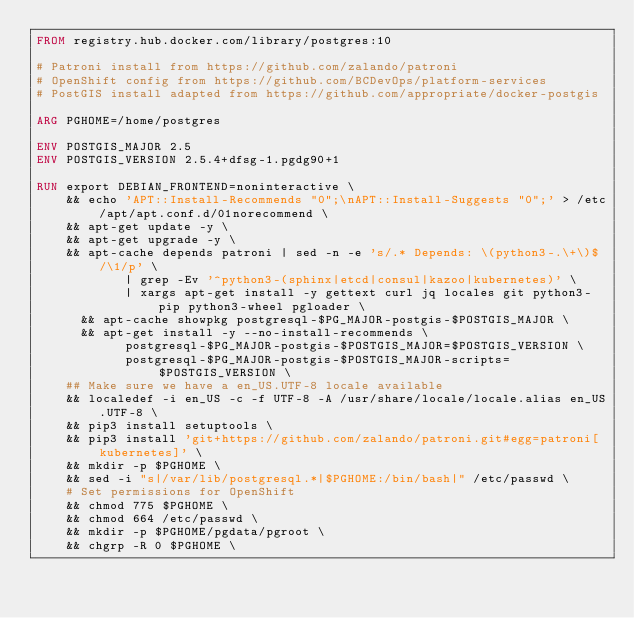Convert code to text. <code><loc_0><loc_0><loc_500><loc_500><_Dockerfile_>FROM registry.hub.docker.com/library/postgres:10

# Patroni install from https://github.com/zalando/patroni
# OpenShift config from https://github.com/BCDevOps/platform-services
# PostGIS install adapted from https://github.com/appropriate/docker-postgis

ARG PGHOME=/home/postgres

ENV POSTGIS_MAJOR 2.5
ENV POSTGIS_VERSION 2.5.4+dfsg-1.pgdg90+1

RUN export DEBIAN_FRONTEND=noninteractive \
    && echo 'APT::Install-Recommends "0";\nAPT::Install-Suggests "0";' > /etc/apt/apt.conf.d/01norecommend \
    && apt-get update -y \
    && apt-get upgrade -y \
    && apt-cache depends patroni | sed -n -e 's/.* Depends: \(python3-.\+\)$/\1/p' \
            | grep -Ev '^python3-(sphinx|etcd|consul|kazoo|kubernetes)' \
            | xargs apt-get install -y gettext curl jq locales git python3-pip python3-wheel pgloader \
      && apt-cache showpkg postgresql-$PG_MAJOR-postgis-$POSTGIS_MAJOR \
      && apt-get install -y --no-install-recommends \
            postgresql-$PG_MAJOR-postgis-$POSTGIS_MAJOR=$POSTGIS_VERSION \
            postgresql-$PG_MAJOR-postgis-$POSTGIS_MAJOR-scripts=$POSTGIS_VERSION \
    ## Make sure we have a en_US.UTF-8 locale available
    && localedef -i en_US -c -f UTF-8 -A /usr/share/locale/locale.alias en_US.UTF-8 \
    && pip3 install setuptools \
    && pip3 install 'git+https://github.com/zalando/patroni.git#egg=patroni[kubernetes]' \
    && mkdir -p $PGHOME \
    && sed -i "s|/var/lib/postgresql.*|$PGHOME:/bin/bash|" /etc/passwd \
    # Set permissions for OpenShift
    && chmod 775 $PGHOME \
    && chmod 664 /etc/passwd \
    && mkdir -p $PGHOME/pgdata/pgroot \
    && chgrp -R 0 $PGHOME \</code> 